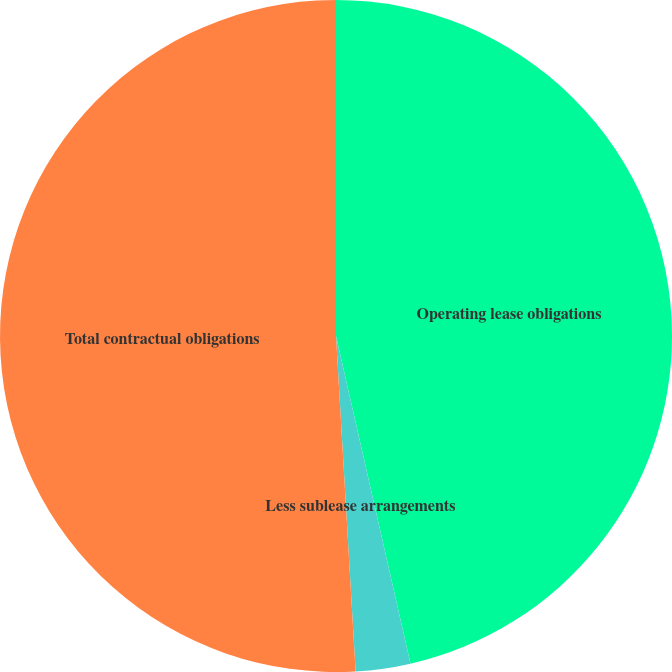Convert chart. <chart><loc_0><loc_0><loc_500><loc_500><pie_chart><fcel>Operating lease obligations<fcel>Less sublease arrangements<fcel>Total contractual obligations<nl><fcel>46.44%<fcel>2.63%<fcel>50.93%<nl></chart> 